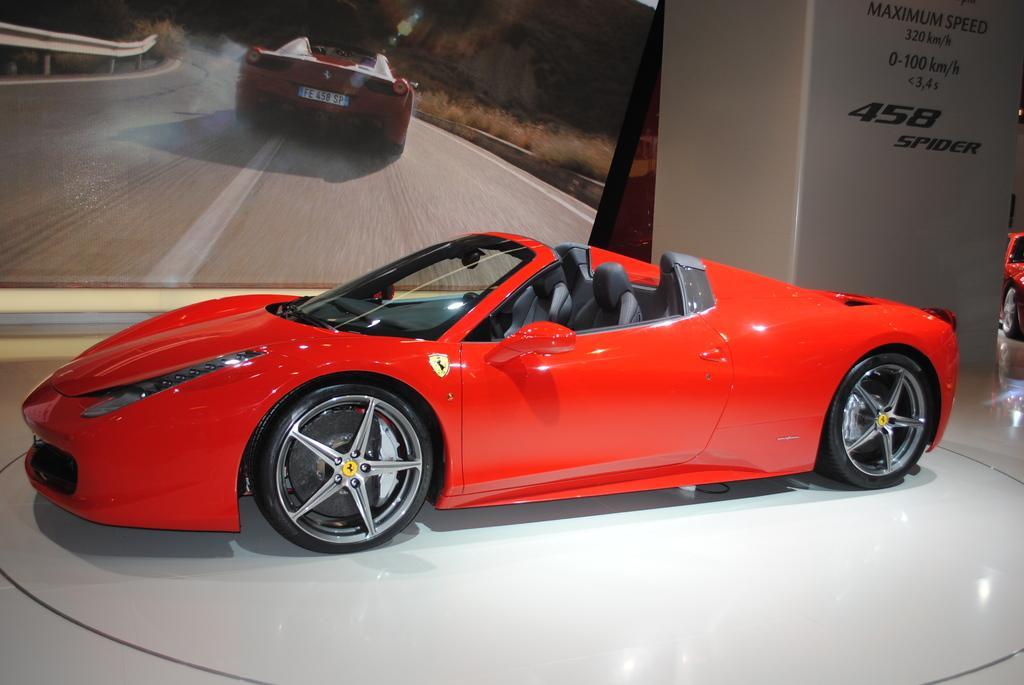Can you describe this image briefly? In this image there is a car on the floor. Right side there is a vehicle on the floor. Beside there is a board having some text. Left side there is a screen. A car on the road is displayed on the screen. Background there is a wall. 